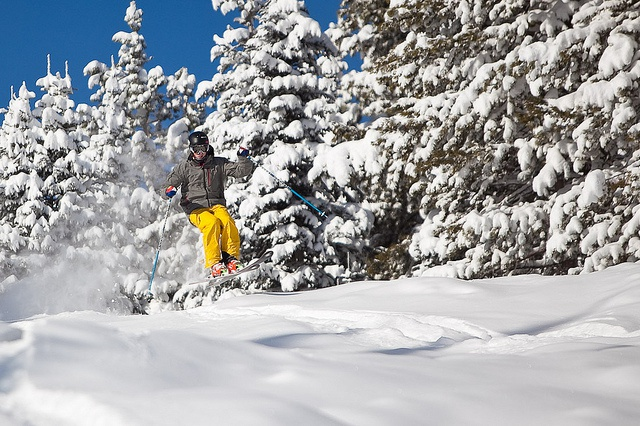Describe the objects in this image and their specific colors. I can see people in blue, black, gray, gold, and darkgray tones and skis in blue, darkgray, gray, lightgray, and black tones in this image. 